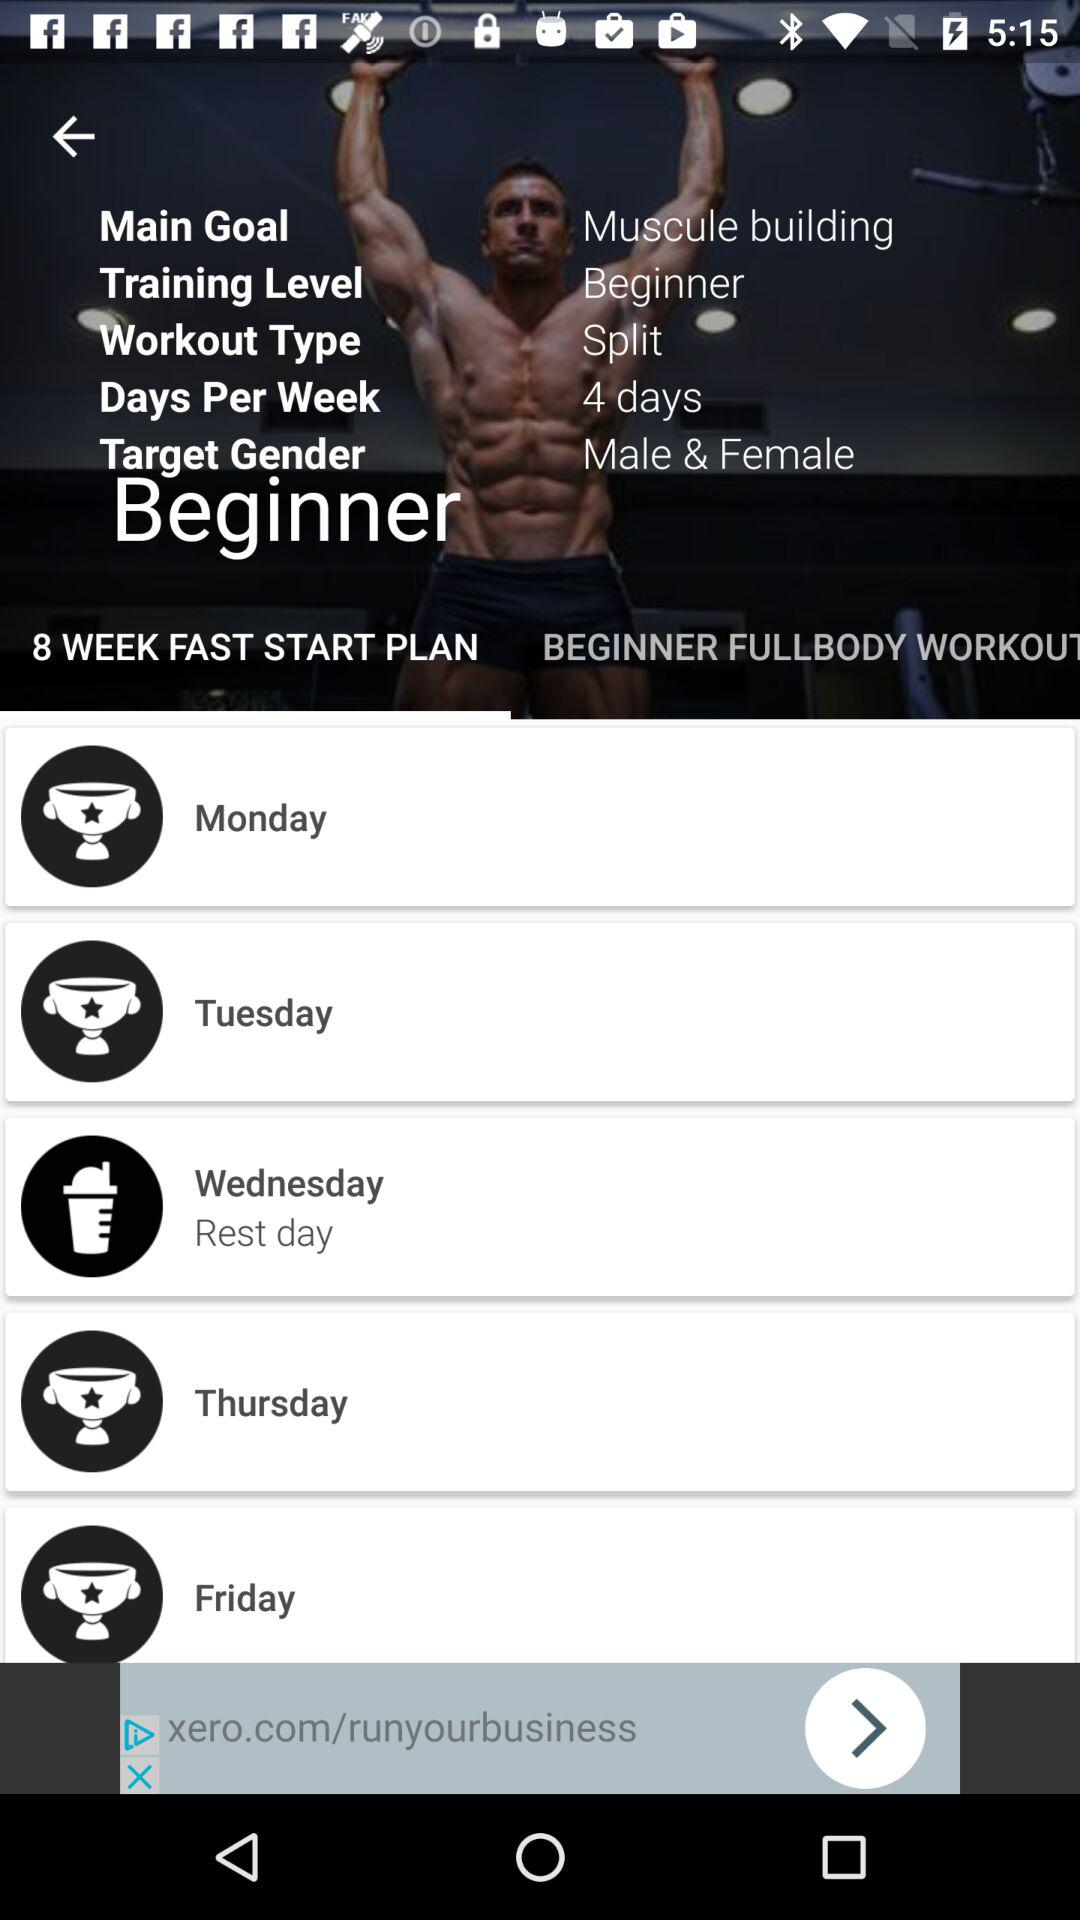What is the workout type? The workout type is split. 